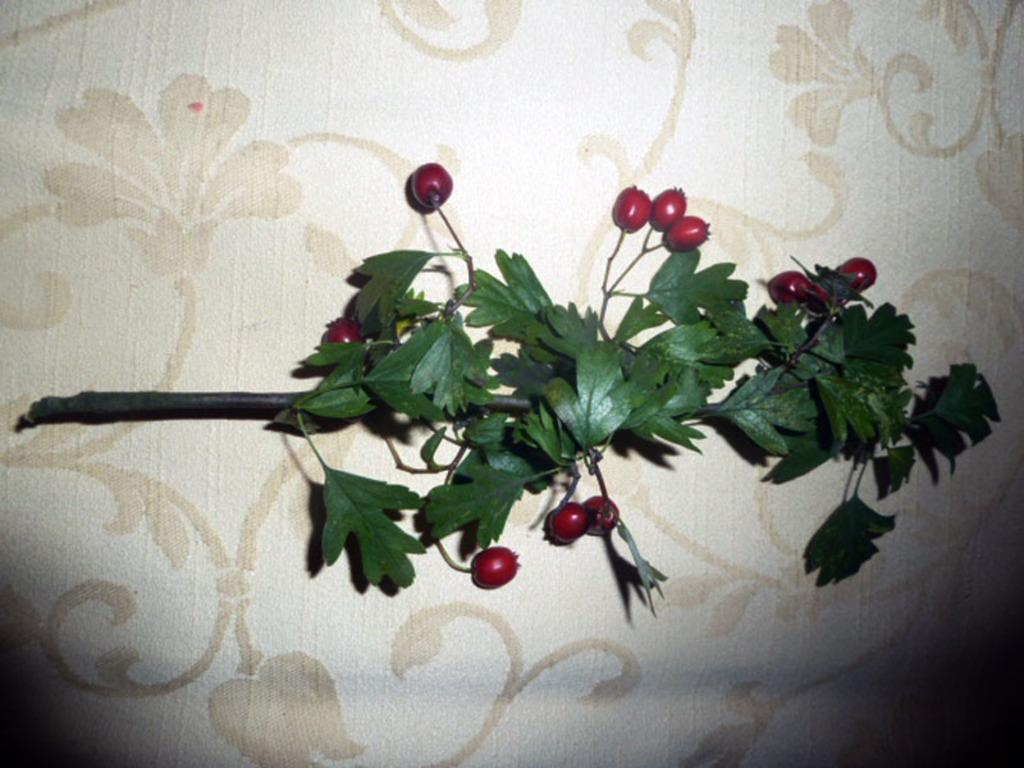What type of fruit is present in the image? There are gooseberries in the image. What else can be seen in the image besides the gooseberries? There are leaves in the image. What type of lace is being used to support the gooseberries in the image? There is no lace present in the image; the gooseberries are resting on leaves. 